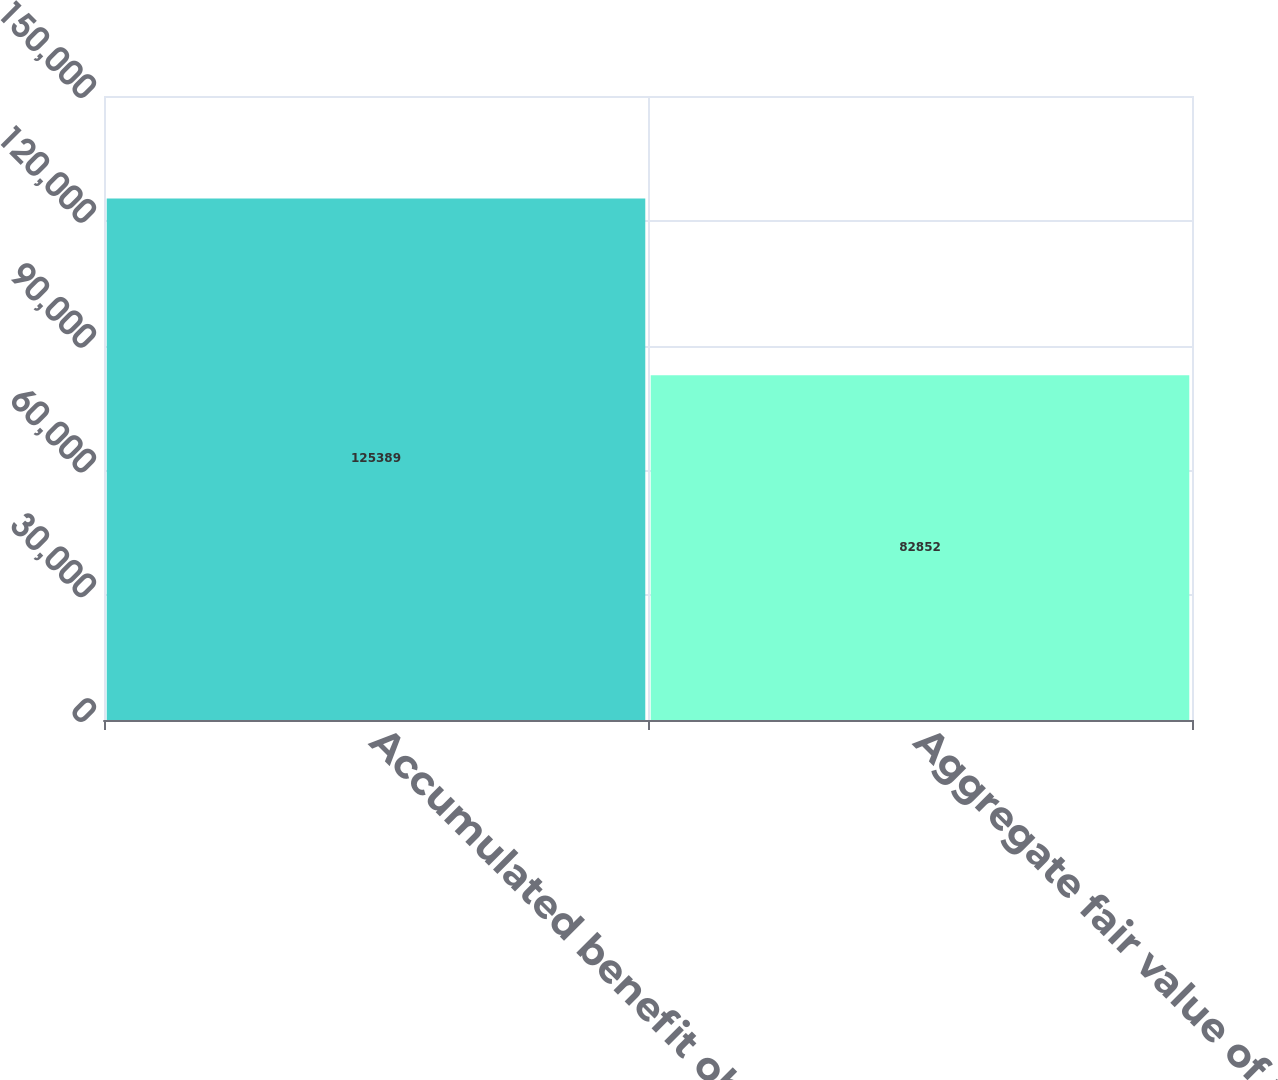<chart> <loc_0><loc_0><loc_500><loc_500><bar_chart><fcel>Accumulated benefit obligation<fcel>Aggregate fair value of plan<nl><fcel>125389<fcel>82852<nl></chart> 